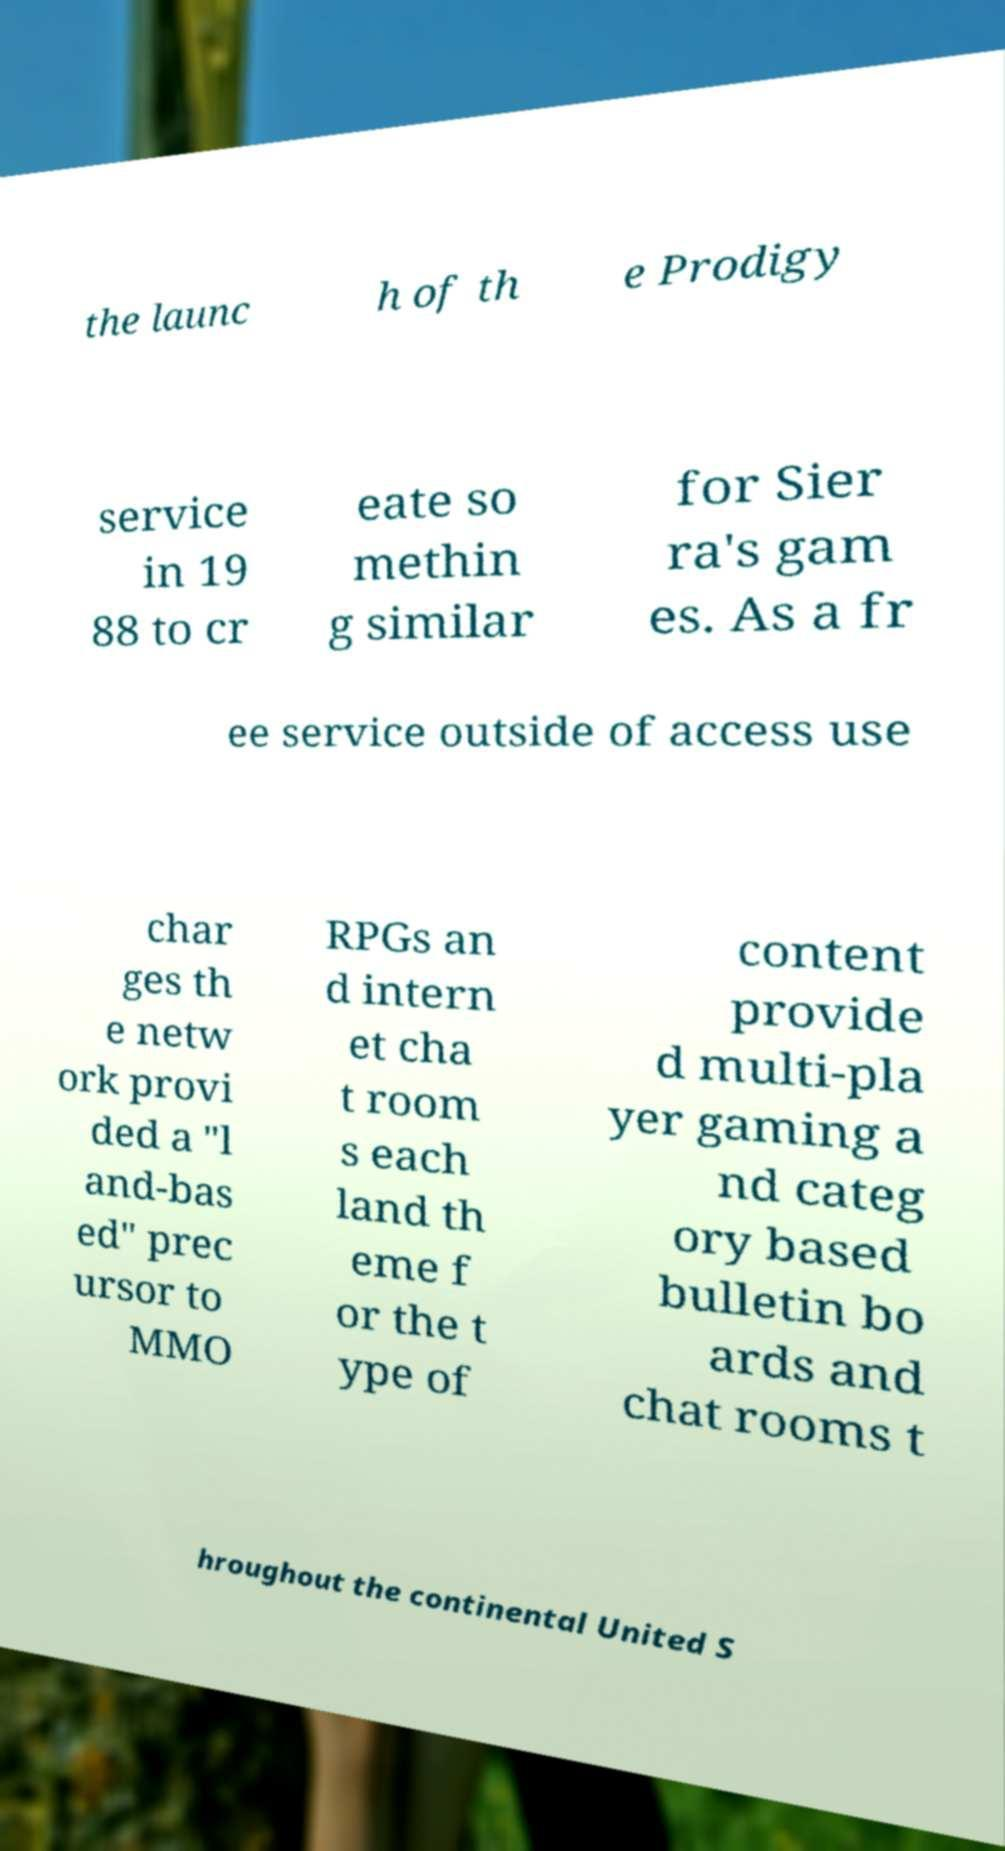I need the written content from this picture converted into text. Can you do that? the launc h of th e Prodigy service in 19 88 to cr eate so methin g similar for Sier ra's gam es. As a fr ee service outside of access use char ges th e netw ork provi ded a "l and-bas ed" prec ursor to MMO RPGs an d intern et cha t room s each land th eme f or the t ype of content provide d multi-pla yer gaming a nd categ ory based bulletin bo ards and chat rooms t hroughout the continental United S 